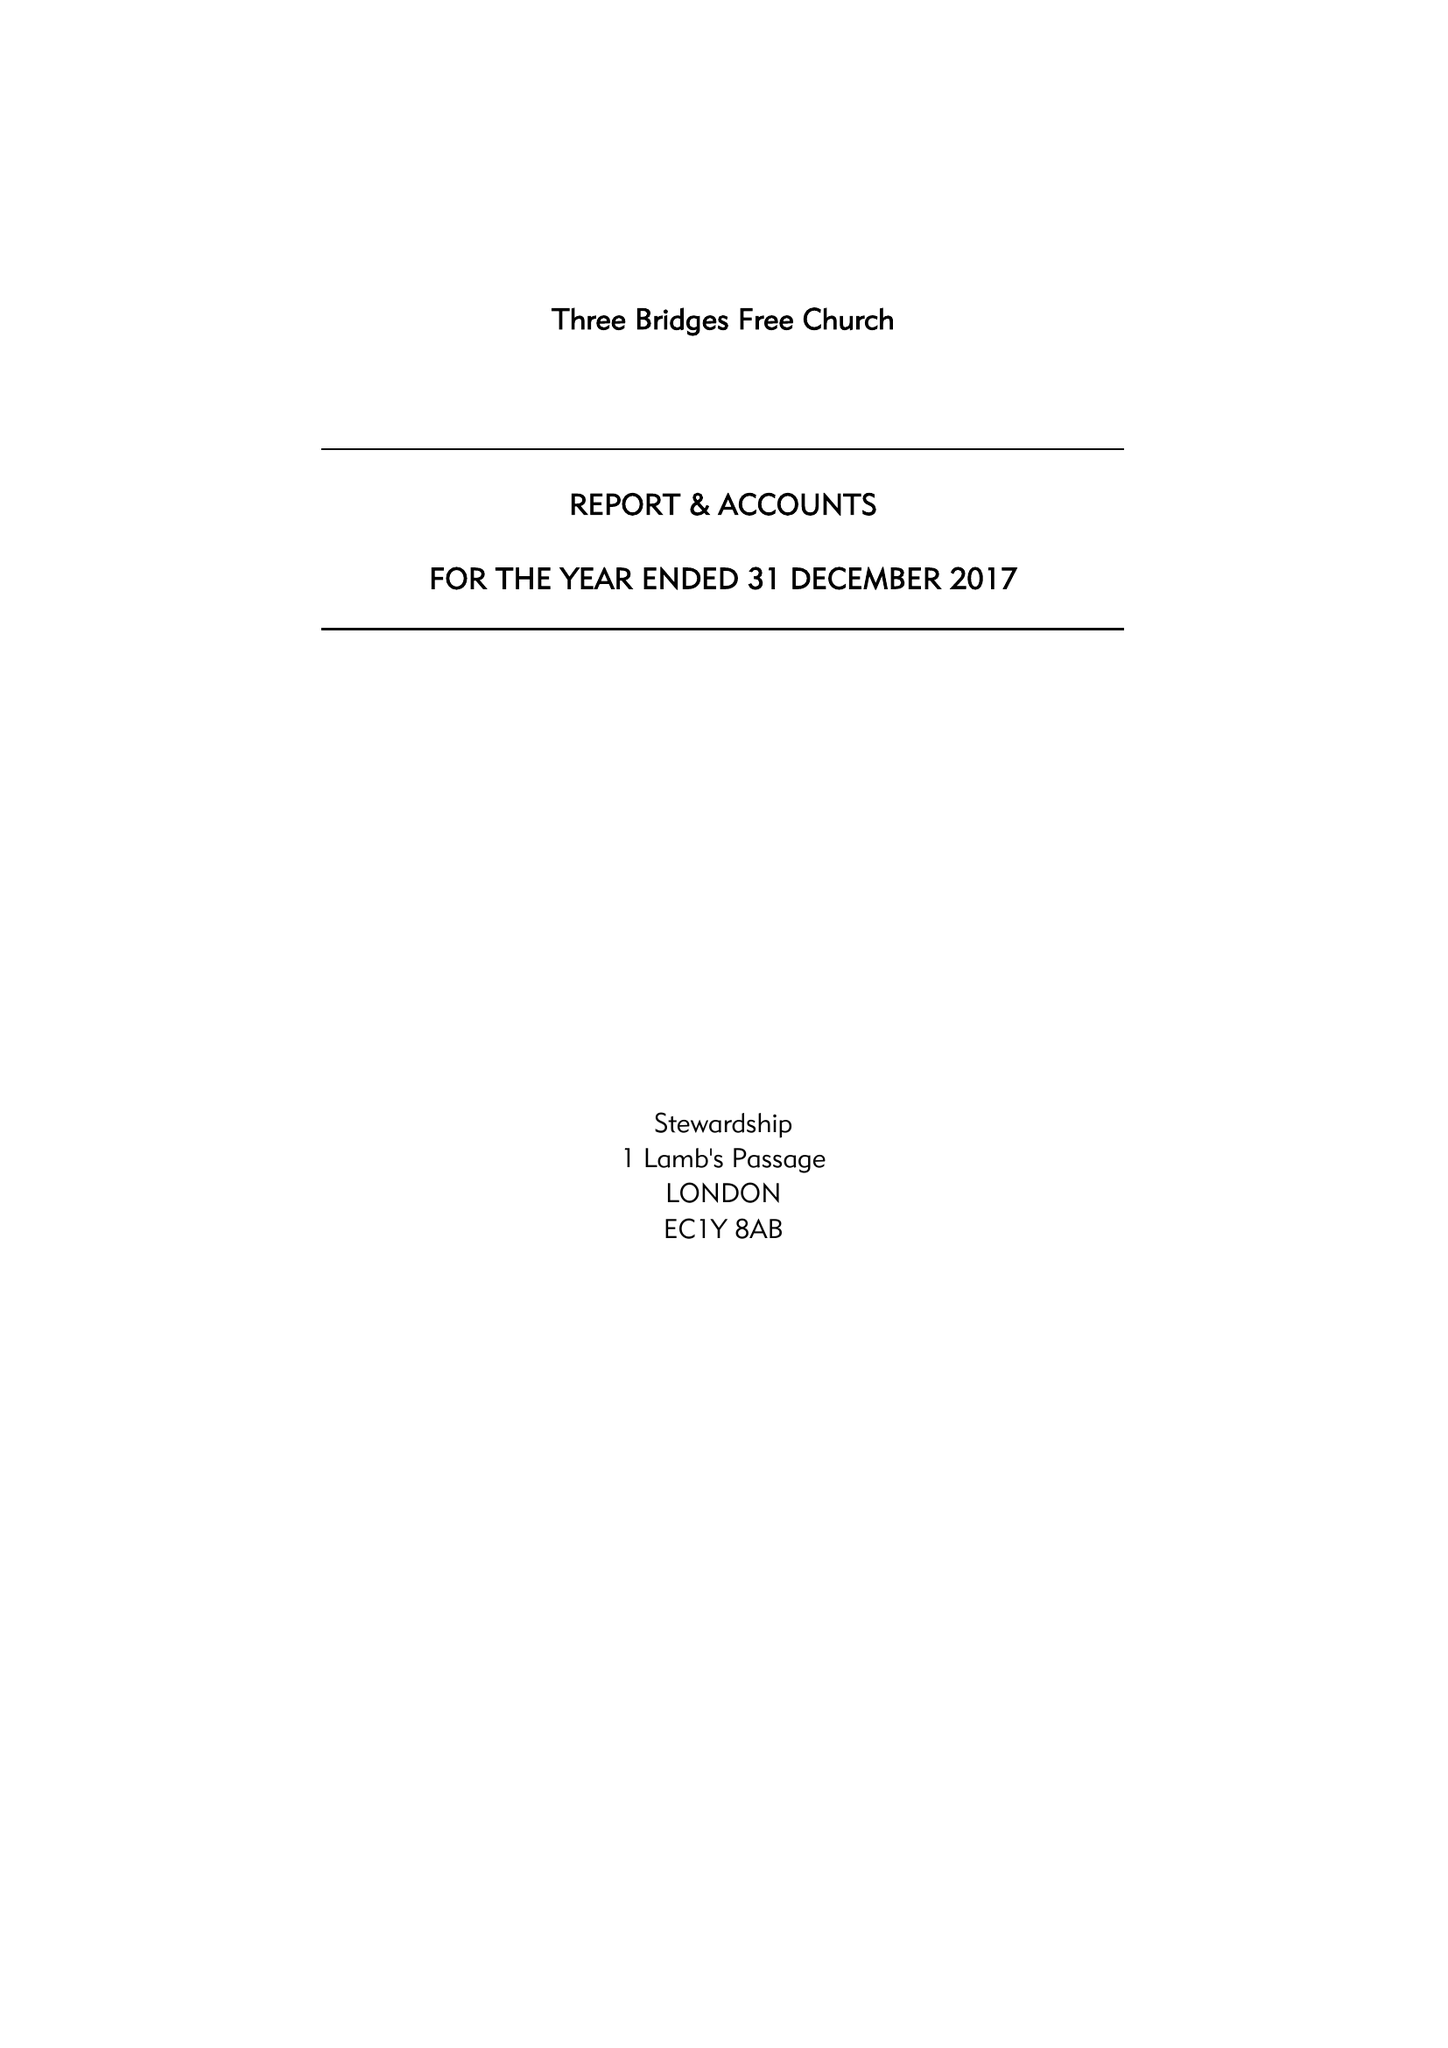What is the value for the charity_number?
Answer the question using a single word or phrase. 1074518 